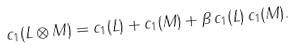<formula> <loc_0><loc_0><loc_500><loc_500>c _ { 1 } ( L \otimes M ) = c _ { 1 } ( L ) + c _ { 1 } ( M ) + \beta \, c _ { 1 } ( L ) \, c _ { 1 } ( M ) .</formula> 